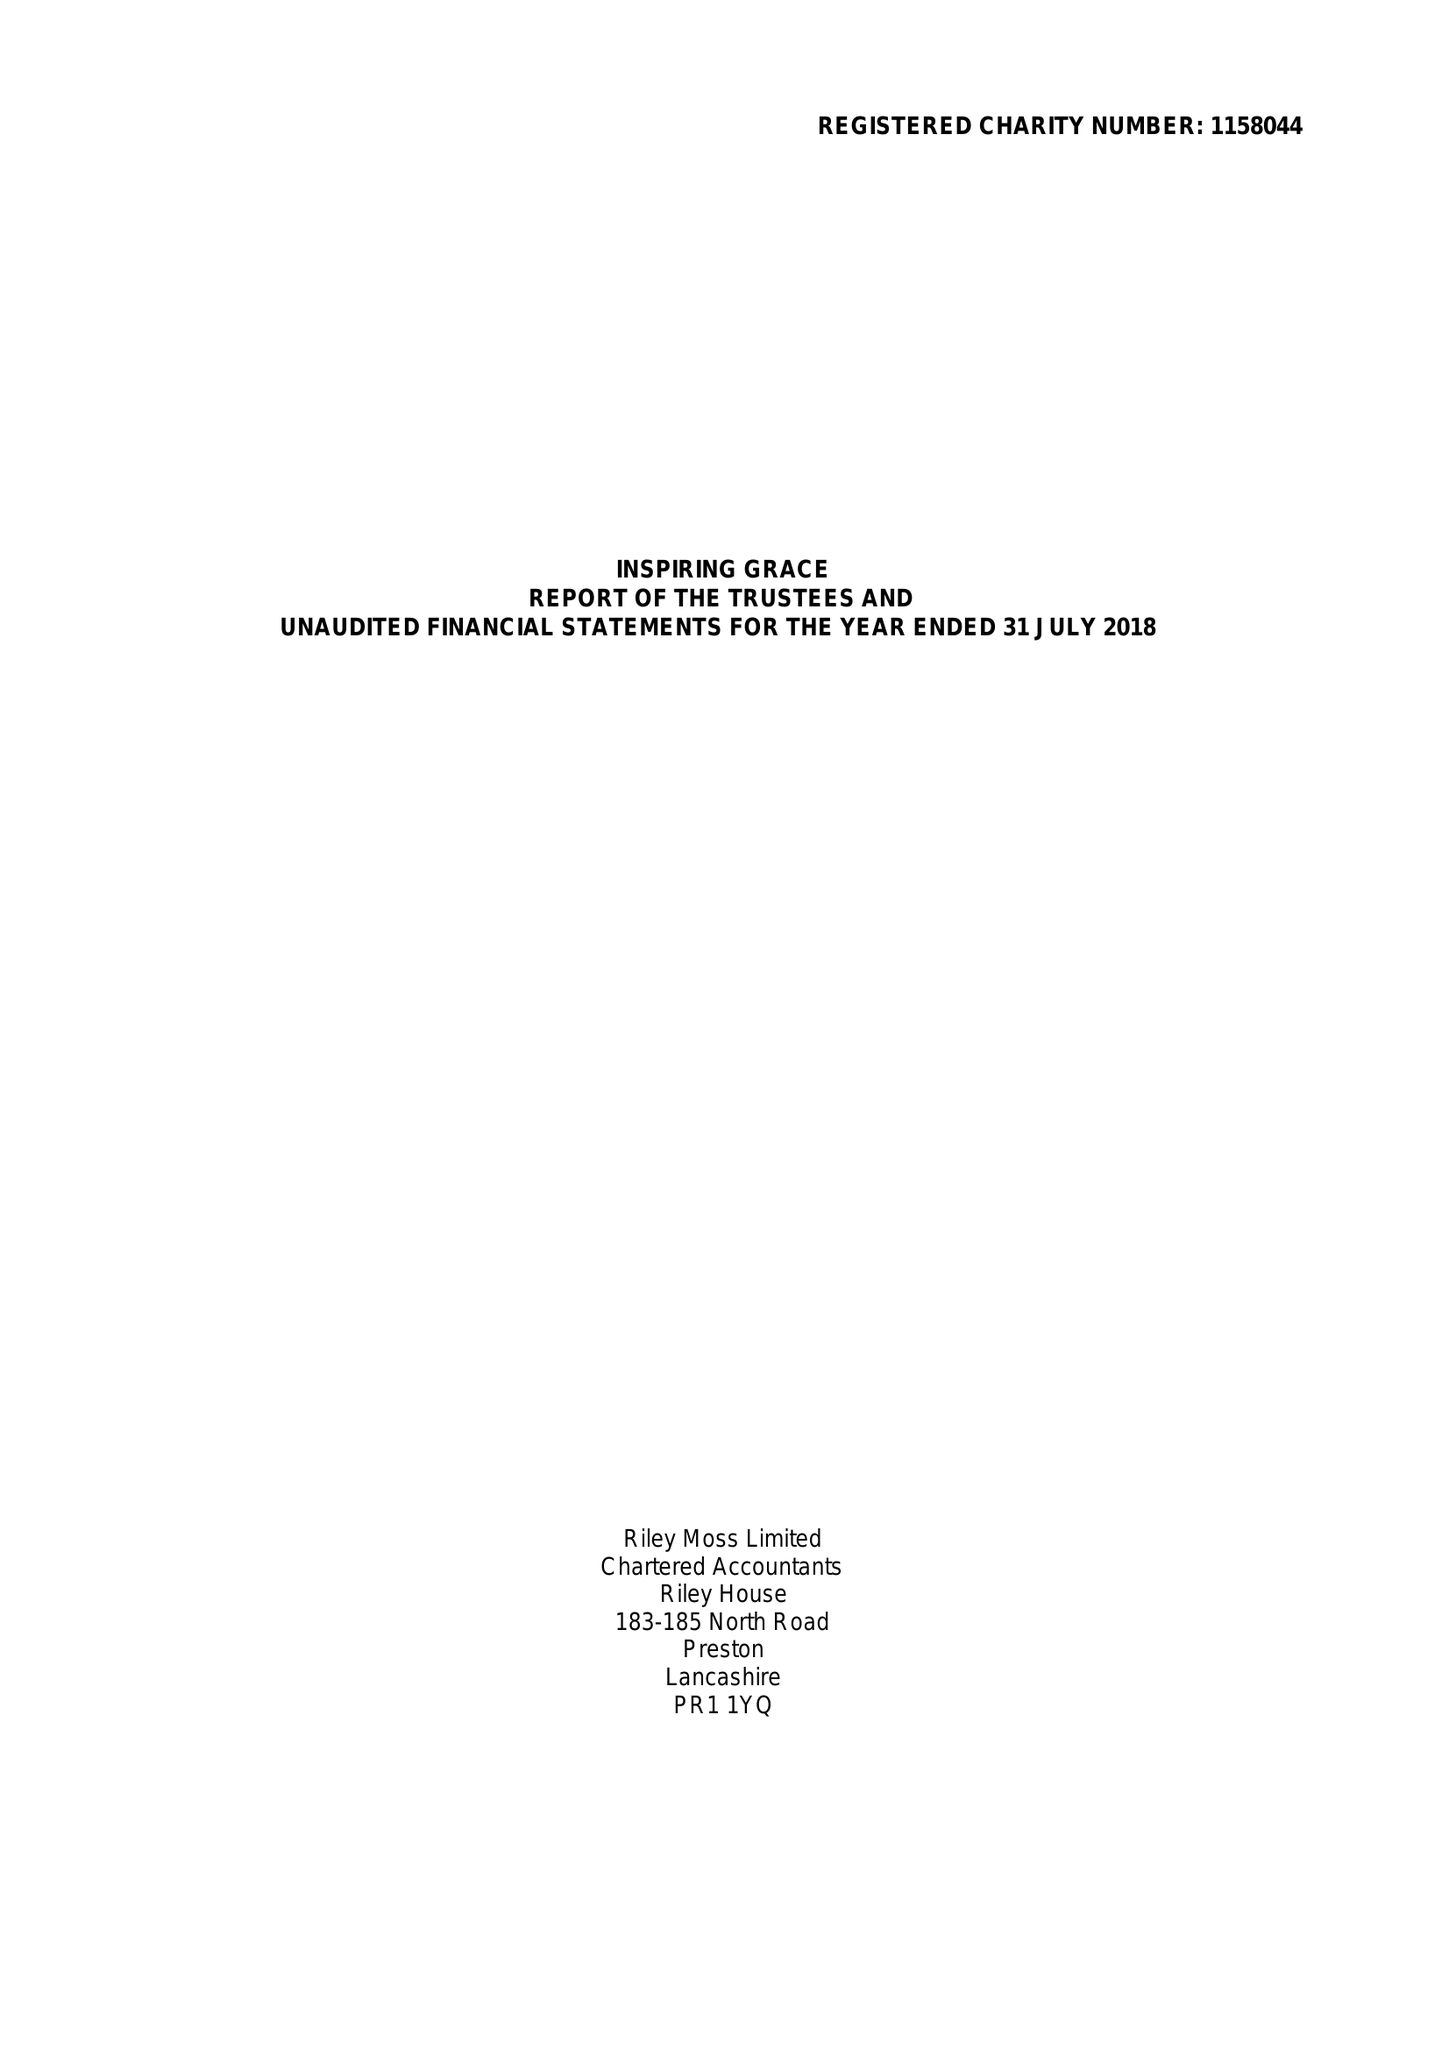What is the value for the income_annually_in_british_pounds?
Answer the question using a single word or phrase. 40463.00 